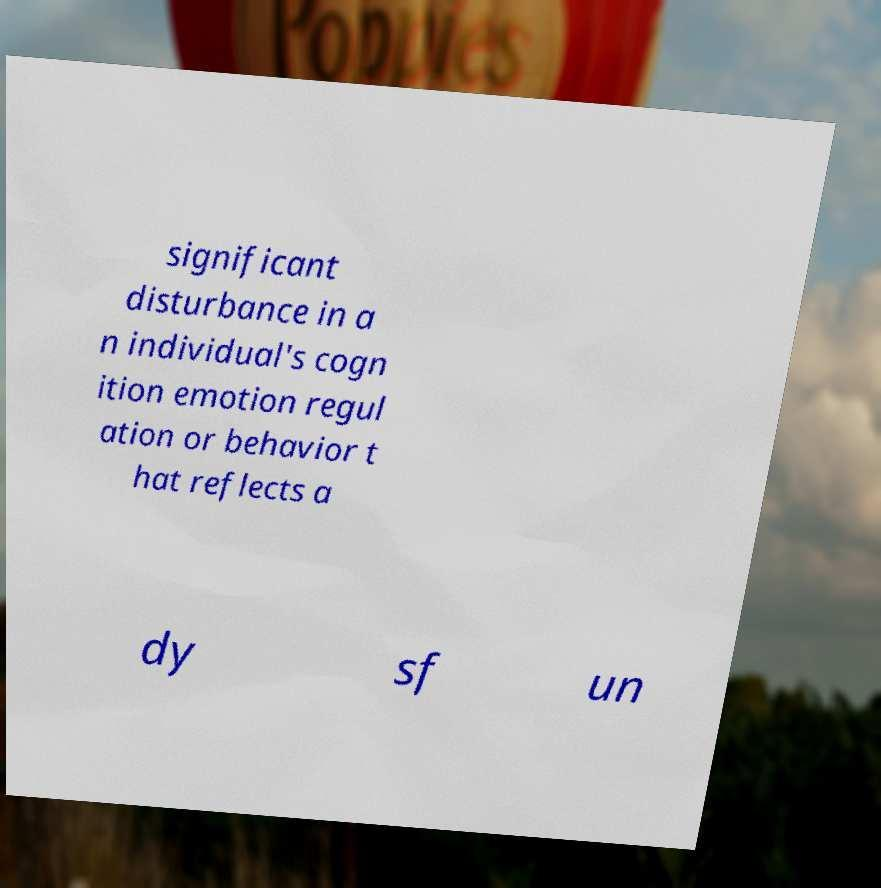Could you extract and type out the text from this image? significant disturbance in a n individual's cogn ition emotion regul ation or behavior t hat reflects a dy sf un 